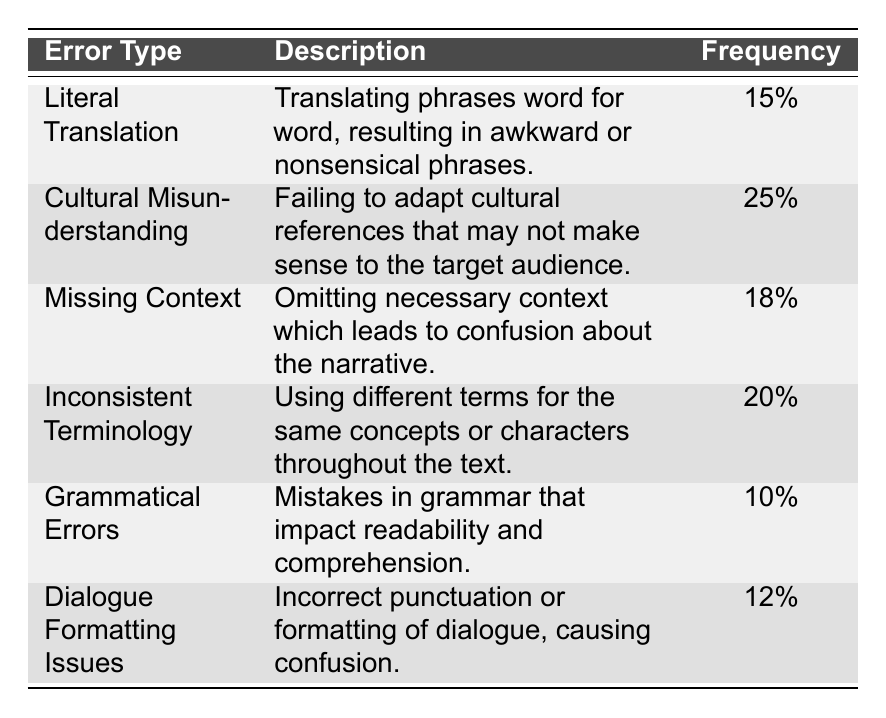What is the most frequent type of translation error? The table shows that "Cultural Misunderstanding" has the highest frequency at 25%.
Answer: Cultural Misunderstanding How many error types have a frequency of 15% or lower? The error types with 15% or lower frequencies are "Grammatical Errors" (10%) and "Literal Translation" (15%). That's a total of 2 error types.
Answer: 2 What is the frequency difference between "Inconsistent Terminology" and "Dialogue Formatting Issues"? "Inconsistent Terminology" has a frequency of 20% and "Dialogue Formatting Issues" has a frequency of 12%. The difference is 20% - 12% = 8%.
Answer: 8% Is there a translation error type that has a frequency of exactly 12%? Yes, "Dialogue Formatting Issues" has a frequency of exactly 12%.
Answer: Yes What is the average frequency of the listed translation error types? To find the average, we sum the frequencies: 15 + 25 + 18 + 20 + 10 + 12 = 110. There are 6 error types, so the average is 110/6 ≈ 18.33%.
Answer: 18.33% Which error type has the lowest frequency and how much is it? "Grammatical Errors" has the lowest frequency at 10%.
Answer: Grammatical Errors, 10% What is the total frequency of "Missing Context" and "Dialogue Formatting Issues"? "Missing Context" has a frequency of 18% and "Dialogue Formatting Issues" has 12%. Their total frequency is 18% + 12% = 30%.
Answer: 30% Are any two error types in the table associated with cultural references? Yes, both "Cultural Misunderstanding" and "Dialogue Formatting Issues" can involve cultural references in some cases.
Answer: Yes 